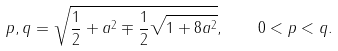Convert formula to latex. <formula><loc_0><loc_0><loc_500><loc_500>p , q = \sqrt { \frac { 1 } { 2 } + a ^ { 2 } \mp \frac { 1 } { 2 } \sqrt { 1 + 8 a ^ { 2 } } } , \quad 0 < p < q .</formula> 